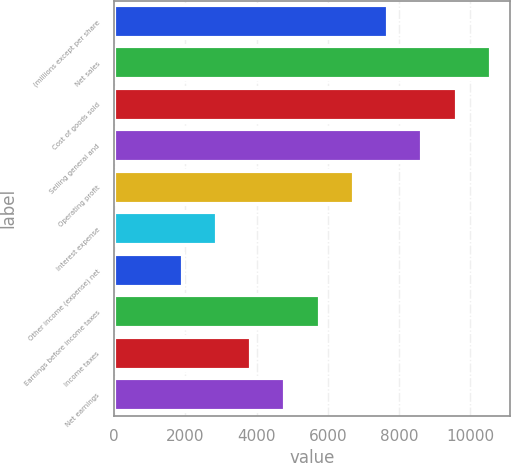<chart> <loc_0><loc_0><loc_500><loc_500><bar_chart><fcel>(millions except per share<fcel>Net sales<fcel>Cost of goods sold<fcel>Selling general and<fcel>Operating profit<fcel>Interest expense<fcel>Other income (expense) net<fcel>Earnings before income taxes<fcel>Income taxes<fcel>Net earnings<nl><fcel>7691.58<fcel>10575.1<fcel>9613.94<fcel>8652.76<fcel>6730.4<fcel>2885.68<fcel>1924.5<fcel>5769.22<fcel>3846.86<fcel>4808.04<nl></chart> 